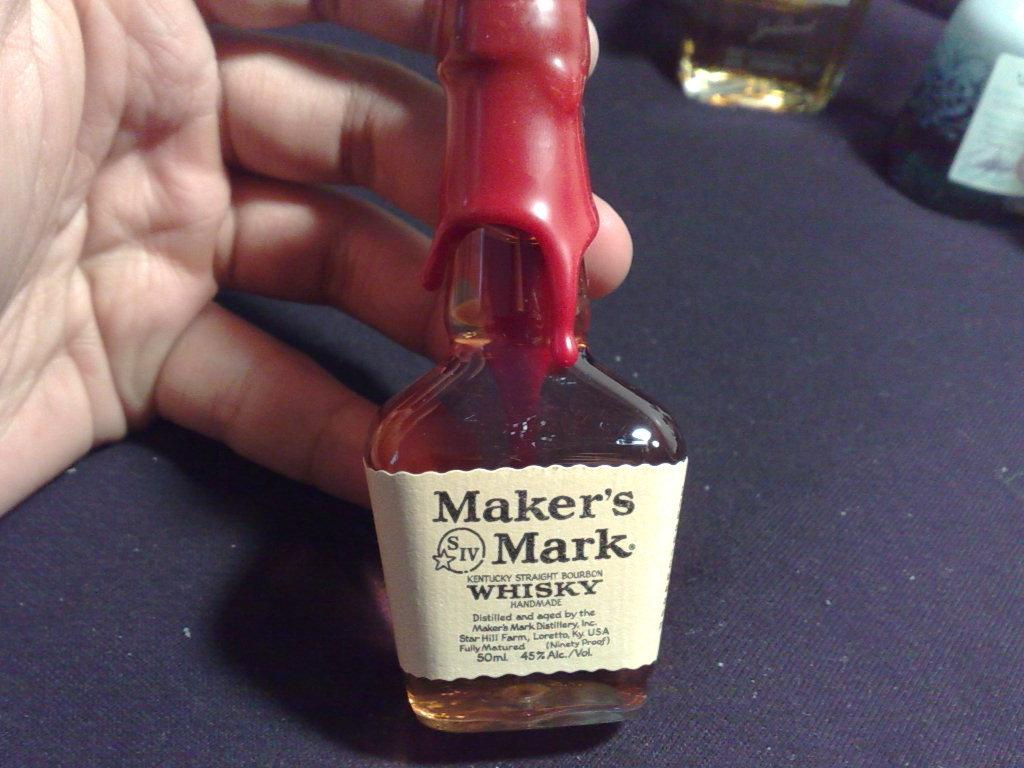What is the main object in the image? There is a wine bottle in the image. Who is holding the wine bottle? The wine bottle is being held by a person. What color is the eye of the person holding the wine bottle? There is no eye visible in the image, as the person holding the wine bottle is not shown. 